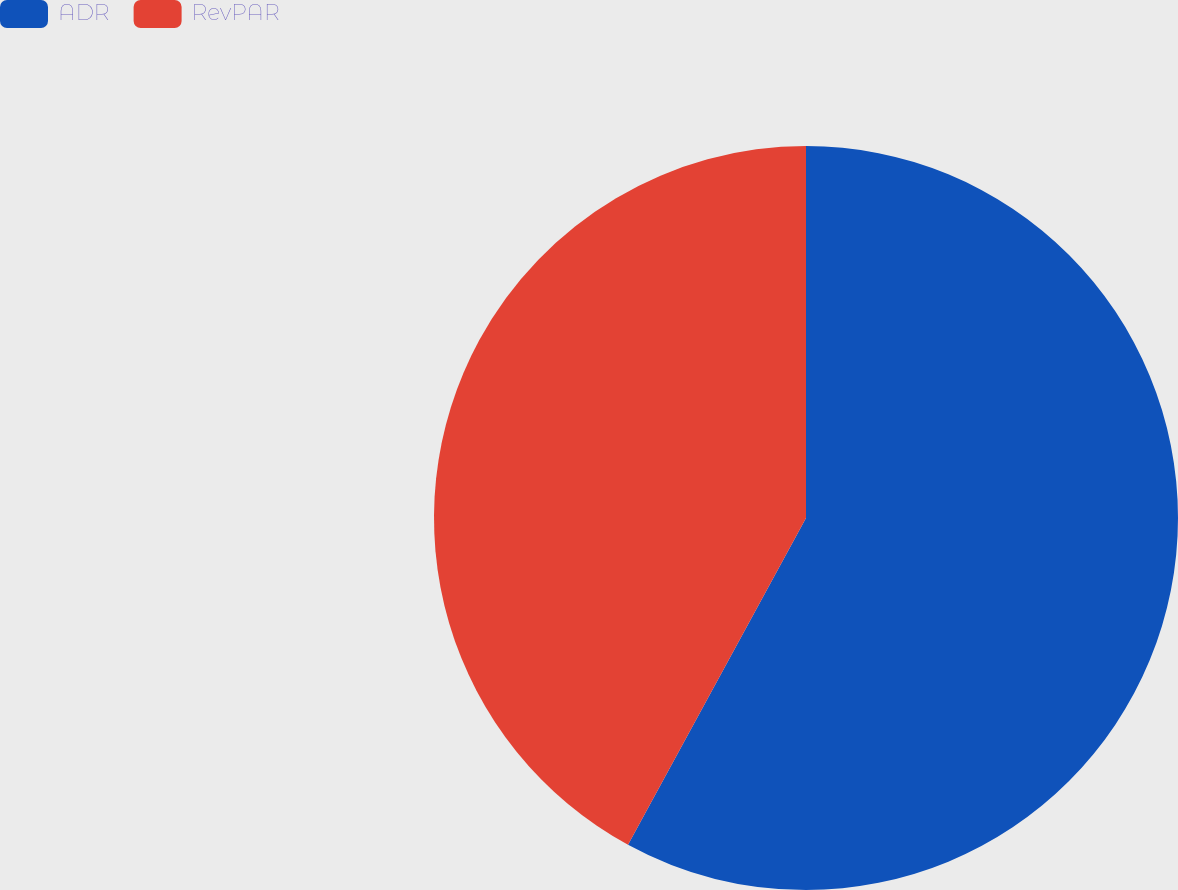<chart> <loc_0><loc_0><loc_500><loc_500><pie_chart><fcel>ADR<fcel>RevPAR<nl><fcel>57.94%<fcel>42.06%<nl></chart> 